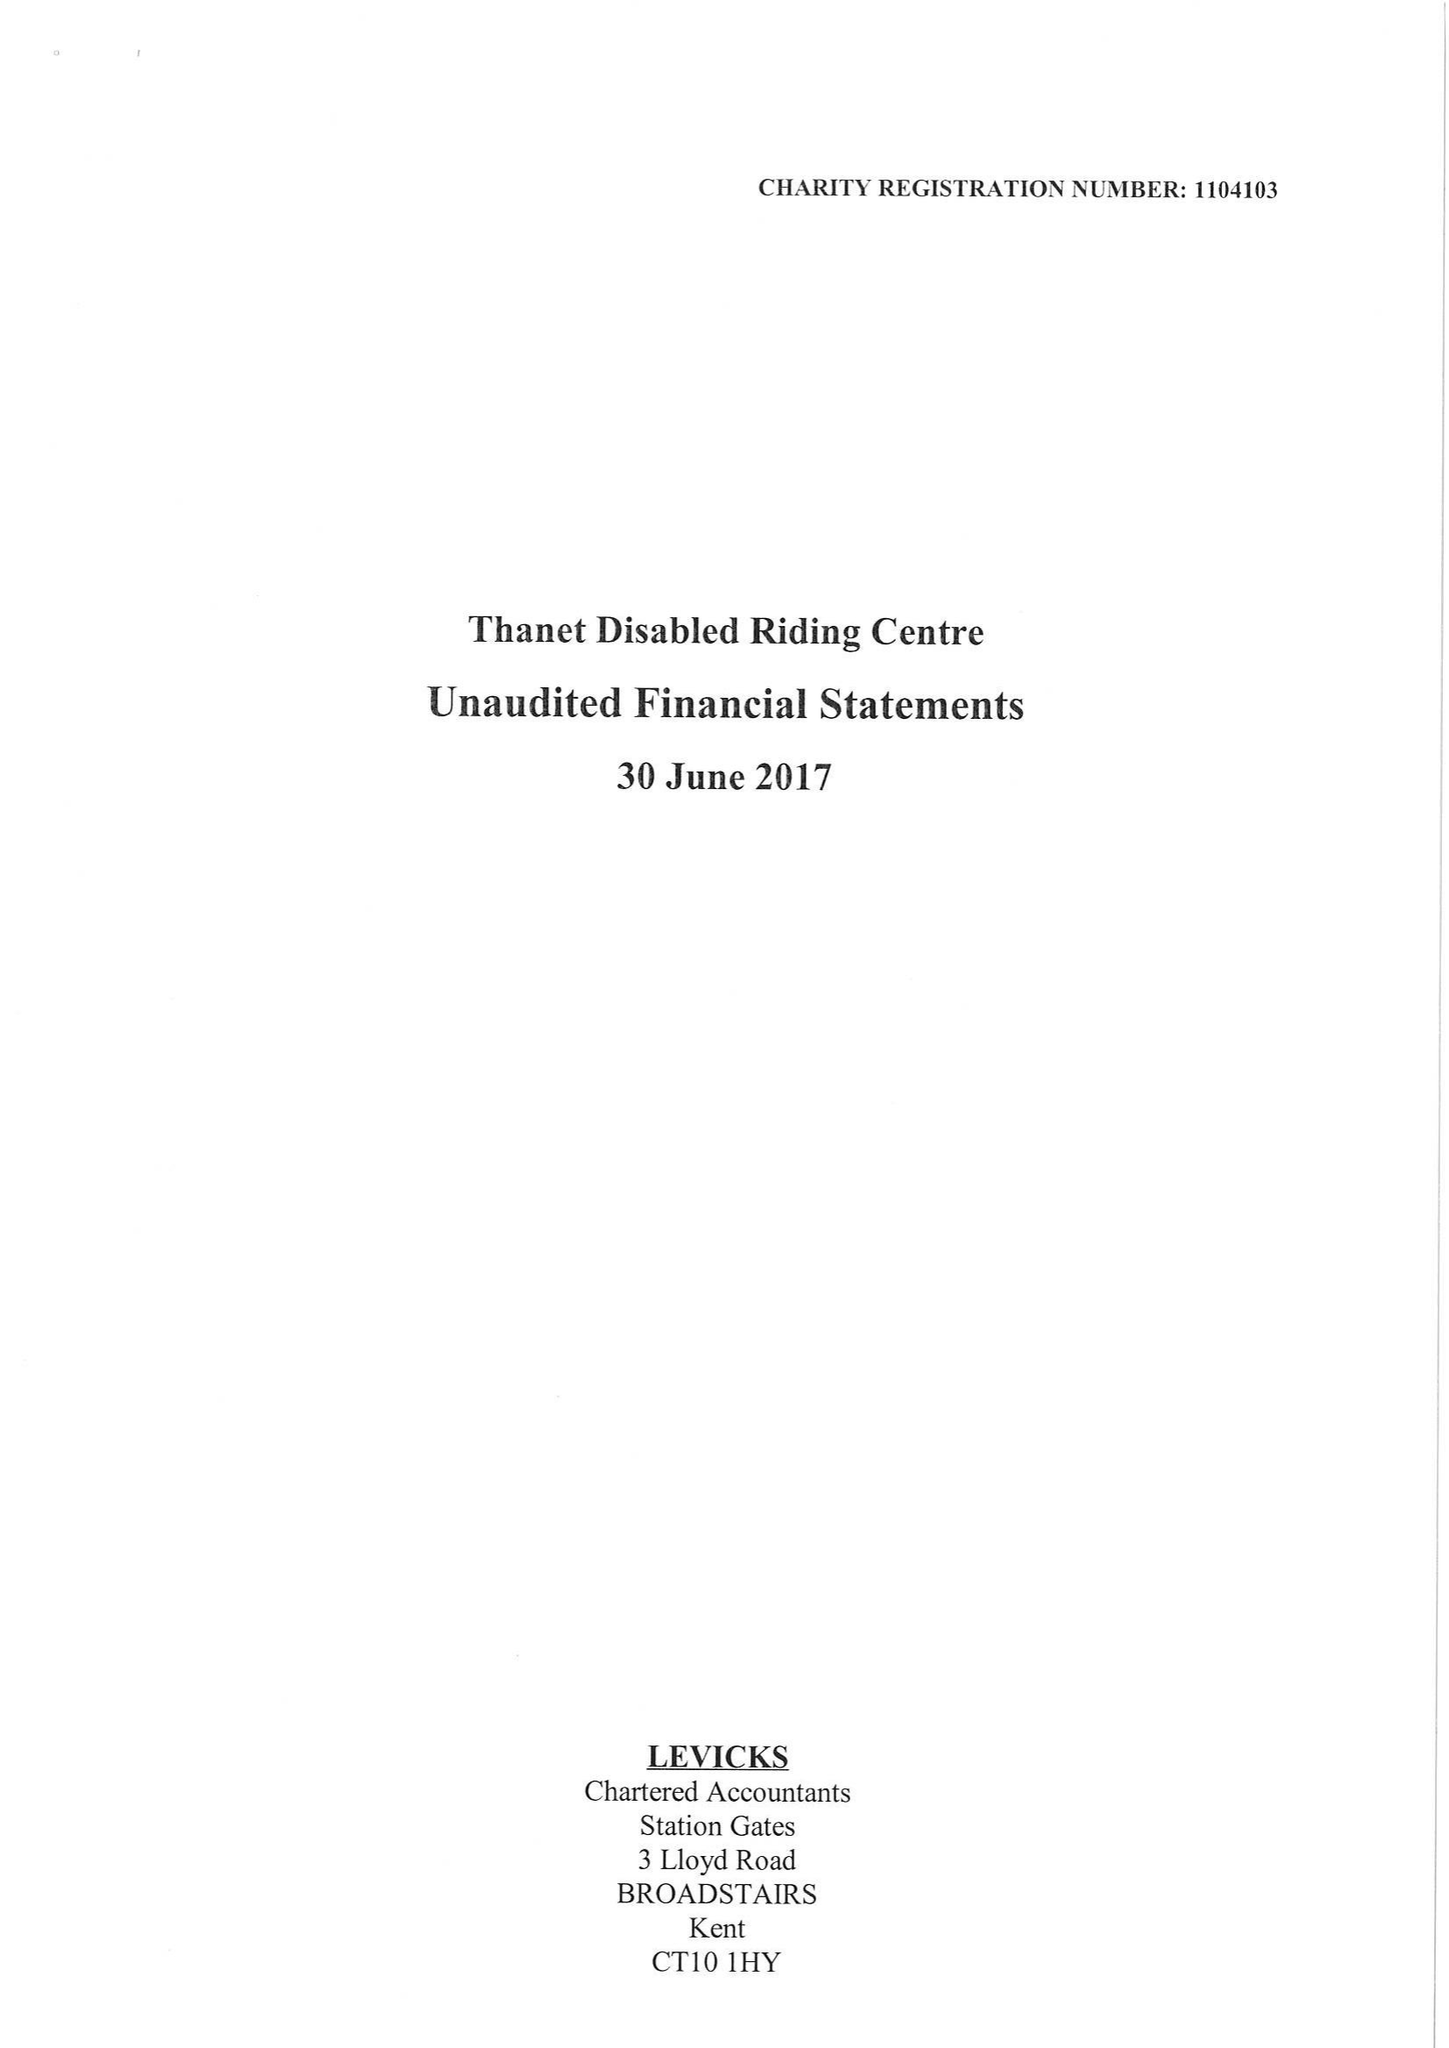What is the value for the charity_name?
Answer the question using a single word or phrase. Thanet Disabled Riding Centre 